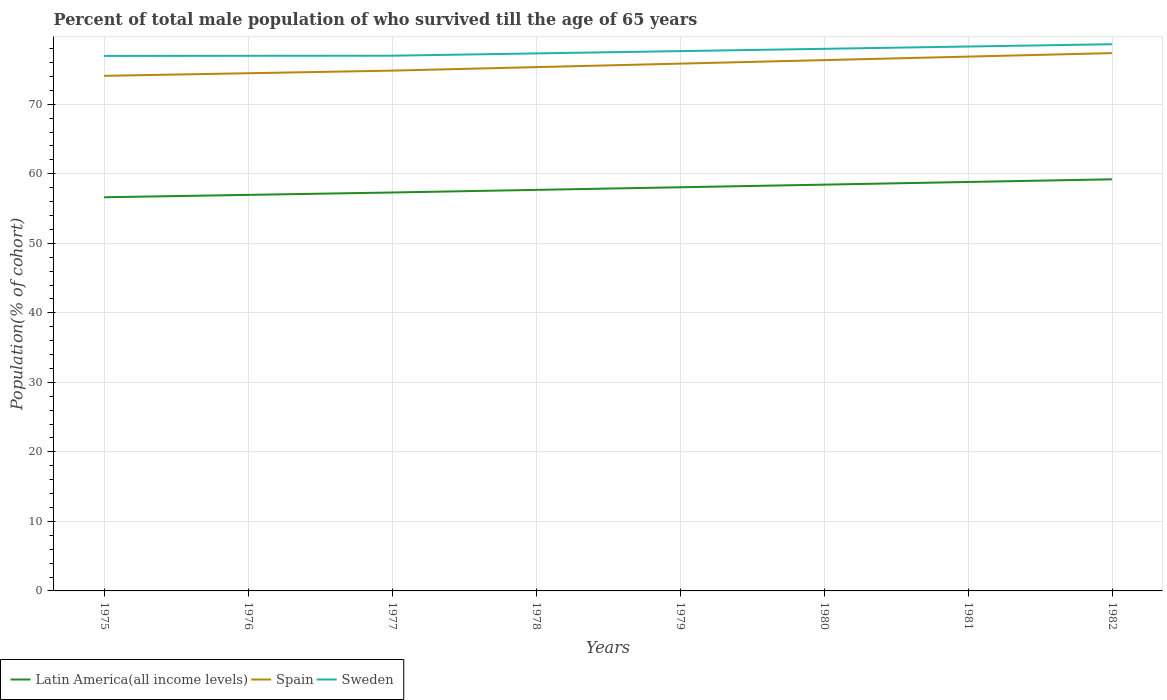Does the line corresponding to Spain intersect with the line corresponding to Sweden?
Give a very brief answer. No. Is the number of lines equal to the number of legend labels?
Keep it short and to the point. Yes. Across all years, what is the maximum percentage of total male population who survived till the age of 65 years in Latin America(all income levels)?
Your answer should be compact. 56.62. In which year was the percentage of total male population who survived till the age of 65 years in Latin America(all income levels) maximum?
Offer a terse response. 1975. What is the total percentage of total male population who survived till the age of 65 years in Sweden in the graph?
Offer a very short reply. -1.65. What is the difference between the highest and the second highest percentage of total male population who survived till the age of 65 years in Spain?
Your answer should be compact. 3.27. What is the difference between the highest and the lowest percentage of total male population who survived till the age of 65 years in Spain?
Your response must be concise. 4. Is the percentage of total male population who survived till the age of 65 years in Sweden strictly greater than the percentage of total male population who survived till the age of 65 years in Latin America(all income levels) over the years?
Your answer should be compact. No. How many years are there in the graph?
Your answer should be compact. 8. What is the difference between two consecutive major ticks on the Y-axis?
Provide a short and direct response. 10. Are the values on the major ticks of Y-axis written in scientific E-notation?
Offer a terse response. No. Does the graph contain any zero values?
Ensure brevity in your answer.  No. How many legend labels are there?
Your response must be concise. 3. How are the legend labels stacked?
Give a very brief answer. Horizontal. What is the title of the graph?
Offer a terse response. Percent of total male population of who survived till the age of 65 years. What is the label or title of the Y-axis?
Your response must be concise. Population(% of cohort). What is the Population(% of cohort) of Latin America(all income levels) in 1975?
Give a very brief answer. 56.62. What is the Population(% of cohort) in Spain in 1975?
Your answer should be very brief. 74.09. What is the Population(% of cohort) of Sweden in 1975?
Provide a succinct answer. 76.96. What is the Population(% of cohort) of Latin America(all income levels) in 1976?
Make the answer very short. 56.97. What is the Population(% of cohort) in Spain in 1976?
Give a very brief answer. 74.46. What is the Population(% of cohort) of Sweden in 1976?
Give a very brief answer. 76.97. What is the Population(% of cohort) in Latin America(all income levels) in 1977?
Provide a succinct answer. 57.31. What is the Population(% of cohort) of Spain in 1977?
Your answer should be compact. 74.84. What is the Population(% of cohort) of Sweden in 1977?
Offer a terse response. 76.99. What is the Population(% of cohort) in Latin America(all income levels) in 1978?
Provide a succinct answer. 57.69. What is the Population(% of cohort) in Spain in 1978?
Provide a succinct answer. 75.34. What is the Population(% of cohort) of Sweden in 1978?
Offer a terse response. 77.32. What is the Population(% of cohort) of Latin America(all income levels) in 1979?
Keep it short and to the point. 58.06. What is the Population(% of cohort) in Spain in 1979?
Offer a terse response. 75.85. What is the Population(% of cohort) in Sweden in 1979?
Give a very brief answer. 77.65. What is the Population(% of cohort) in Latin America(all income levels) in 1980?
Keep it short and to the point. 58.44. What is the Population(% of cohort) in Spain in 1980?
Make the answer very short. 76.35. What is the Population(% of cohort) of Sweden in 1980?
Your response must be concise. 77.98. What is the Population(% of cohort) of Latin America(all income levels) in 1981?
Your answer should be compact. 58.82. What is the Population(% of cohort) of Spain in 1981?
Offer a terse response. 76.86. What is the Population(% of cohort) of Sweden in 1981?
Provide a short and direct response. 78.31. What is the Population(% of cohort) of Latin America(all income levels) in 1982?
Keep it short and to the point. 59.21. What is the Population(% of cohort) in Spain in 1982?
Your answer should be compact. 77.36. What is the Population(% of cohort) of Sweden in 1982?
Your answer should be very brief. 78.64. Across all years, what is the maximum Population(% of cohort) of Latin America(all income levels)?
Your response must be concise. 59.21. Across all years, what is the maximum Population(% of cohort) of Spain?
Your answer should be compact. 77.36. Across all years, what is the maximum Population(% of cohort) in Sweden?
Your response must be concise. 78.64. Across all years, what is the minimum Population(% of cohort) of Latin America(all income levels)?
Ensure brevity in your answer.  56.62. Across all years, what is the minimum Population(% of cohort) of Spain?
Ensure brevity in your answer.  74.09. Across all years, what is the minimum Population(% of cohort) in Sweden?
Offer a terse response. 76.96. What is the total Population(% of cohort) of Latin America(all income levels) in the graph?
Give a very brief answer. 463.12. What is the total Population(% of cohort) in Spain in the graph?
Give a very brief answer. 605.15. What is the total Population(% of cohort) of Sweden in the graph?
Offer a terse response. 620.8. What is the difference between the Population(% of cohort) in Latin America(all income levels) in 1975 and that in 1976?
Keep it short and to the point. -0.34. What is the difference between the Population(% of cohort) of Spain in 1975 and that in 1976?
Your answer should be compact. -0.37. What is the difference between the Population(% of cohort) in Sweden in 1975 and that in 1976?
Offer a terse response. -0.01. What is the difference between the Population(% of cohort) of Latin America(all income levels) in 1975 and that in 1977?
Ensure brevity in your answer.  -0.68. What is the difference between the Population(% of cohort) of Spain in 1975 and that in 1977?
Offer a very short reply. -0.75. What is the difference between the Population(% of cohort) of Sweden in 1975 and that in 1977?
Offer a terse response. -0.03. What is the difference between the Population(% of cohort) in Latin America(all income levels) in 1975 and that in 1978?
Give a very brief answer. -1.06. What is the difference between the Population(% of cohort) of Spain in 1975 and that in 1978?
Provide a succinct answer. -1.25. What is the difference between the Population(% of cohort) in Sweden in 1975 and that in 1978?
Provide a short and direct response. -0.36. What is the difference between the Population(% of cohort) of Latin America(all income levels) in 1975 and that in 1979?
Your answer should be compact. -1.44. What is the difference between the Population(% of cohort) in Spain in 1975 and that in 1979?
Your response must be concise. -1.76. What is the difference between the Population(% of cohort) of Sweden in 1975 and that in 1979?
Keep it short and to the point. -0.69. What is the difference between the Population(% of cohort) in Latin America(all income levels) in 1975 and that in 1980?
Your answer should be compact. -1.82. What is the difference between the Population(% of cohort) of Spain in 1975 and that in 1980?
Provide a short and direct response. -2.26. What is the difference between the Population(% of cohort) of Sweden in 1975 and that in 1980?
Provide a short and direct response. -1.02. What is the difference between the Population(% of cohort) of Latin America(all income levels) in 1975 and that in 1981?
Offer a terse response. -2.2. What is the difference between the Population(% of cohort) in Spain in 1975 and that in 1981?
Your answer should be compact. -2.77. What is the difference between the Population(% of cohort) of Sweden in 1975 and that in 1981?
Provide a short and direct response. -1.35. What is the difference between the Population(% of cohort) in Latin America(all income levels) in 1975 and that in 1982?
Your answer should be compact. -2.58. What is the difference between the Population(% of cohort) in Spain in 1975 and that in 1982?
Give a very brief answer. -3.27. What is the difference between the Population(% of cohort) of Sweden in 1975 and that in 1982?
Offer a terse response. -1.68. What is the difference between the Population(% of cohort) in Latin America(all income levels) in 1976 and that in 1977?
Your answer should be very brief. -0.34. What is the difference between the Population(% of cohort) of Spain in 1976 and that in 1977?
Your answer should be compact. -0.37. What is the difference between the Population(% of cohort) in Sweden in 1976 and that in 1977?
Ensure brevity in your answer.  -0.01. What is the difference between the Population(% of cohort) in Latin America(all income levels) in 1976 and that in 1978?
Provide a short and direct response. -0.72. What is the difference between the Population(% of cohort) in Spain in 1976 and that in 1978?
Your answer should be compact. -0.88. What is the difference between the Population(% of cohort) of Sweden in 1976 and that in 1978?
Provide a short and direct response. -0.34. What is the difference between the Population(% of cohort) in Latin America(all income levels) in 1976 and that in 1979?
Your response must be concise. -1.1. What is the difference between the Population(% of cohort) of Spain in 1976 and that in 1979?
Your answer should be very brief. -1.38. What is the difference between the Population(% of cohort) of Sweden in 1976 and that in 1979?
Keep it short and to the point. -0.67. What is the difference between the Population(% of cohort) in Latin America(all income levels) in 1976 and that in 1980?
Your response must be concise. -1.47. What is the difference between the Population(% of cohort) in Spain in 1976 and that in 1980?
Keep it short and to the point. -1.89. What is the difference between the Population(% of cohort) of Sweden in 1976 and that in 1980?
Ensure brevity in your answer.  -1. What is the difference between the Population(% of cohort) in Latin America(all income levels) in 1976 and that in 1981?
Ensure brevity in your answer.  -1.86. What is the difference between the Population(% of cohort) of Spain in 1976 and that in 1981?
Make the answer very short. -2.39. What is the difference between the Population(% of cohort) of Sweden in 1976 and that in 1981?
Your answer should be very brief. -1.33. What is the difference between the Population(% of cohort) in Latin America(all income levels) in 1976 and that in 1982?
Provide a short and direct response. -2.24. What is the difference between the Population(% of cohort) of Spain in 1976 and that in 1982?
Provide a succinct answer. -2.9. What is the difference between the Population(% of cohort) in Sweden in 1976 and that in 1982?
Ensure brevity in your answer.  -1.67. What is the difference between the Population(% of cohort) in Latin America(all income levels) in 1977 and that in 1978?
Provide a succinct answer. -0.38. What is the difference between the Population(% of cohort) of Spain in 1977 and that in 1978?
Offer a very short reply. -0.5. What is the difference between the Population(% of cohort) in Sweden in 1977 and that in 1978?
Offer a very short reply. -0.33. What is the difference between the Population(% of cohort) in Latin America(all income levels) in 1977 and that in 1979?
Give a very brief answer. -0.75. What is the difference between the Population(% of cohort) of Spain in 1977 and that in 1979?
Offer a very short reply. -1.01. What is the difference between the Population(% of cohort) of Sweden in 1977 and that in 1979?
Ensure brevity in your answer.  -0.66. What is the difference between the Population(% of cohort) of Latin America(all income levels) in 1977 and that in 1980?
Offer a terse response. -1.13. What is the difference between the Population(% of cohort) in Spain in 1977 and that in 1980?
Make the answer very short. -1.51. What is the difference between the Population(% of cohort) in Sweden in 1977 and that in 1980?
Keep it short and to the point. -0.99. What is the difference between the Population(% of cohort) of Latin America(all income levels) in 1977 and that in 1981?
Provide a short and direct response. -1.52. What is the difference between the Population(% of cohort) of Spain in 1977 and that in 1981?
Keep it short and to the point. -2.02. What is the difference between the Population(% of cohort) of Sweden in 1977 and that in 1981?
Your answer should be compact. -1.32. What is the difference between the Population(% of cohort) in Latin America(all income levels) in 1977 and that in 1982?
Offer a terse response. -1.9. What is the difference between the Population(% of cohort) in Spain in 1977 and that in 1982?
Your answer should be compact. -2.52. What is the difference between the Population(% of cohort) in Sweden in 1977 and that in 1982?
Provide a succinct answer. -1.65. What is the difference between the Population(% of cohort) in Latin America(all income levels) in 1978 and that in 1979?
Your response must be concise. -0.38. What is the difference between the Population(% of cohort) of Spain in 1978 and that in 1979?
Offer a terse response. -0.5. What is the difference between the Population(% of cohort) of Sweden in 1978 and that in 1979?
Provide a succinct answer. -0.33. What is the difference between the Population(% of cohort) in Latin America(all income levels) in 1978 and that in 1980?
Offer a very short reply. -0.75. What is the difference between the Population(% of cohort) in Spain in 1978 and that in 1980?
Give a very brief answer. -1.01. What is the difference between the Population(% of cohort) in Sweden in 1978 and that in 1980?
Your response must be concise. -0.66. What is the difference between the Population(% of cohort) of Latin America(all income levels) in 1978 and that in 1981?
Your response must be concise. -1.14. What is the difference between the Population(% of cohort) in Spain in 1978 and that in 1981?
Give a very brief answer. -1.51. What is the difference between the Population(% of cohort) of Sweden in 1978 and that in 1981?
Offer a very short reply. -0.99. What is the difference between the Population(% of cohort) of Latin America(all income levels) in 1978 and that in 1982?
Make the answer very short. -1.52. What is the difference between the Population(% of cohort) of Spain in 1978 and that in 1982?
Your answer should be very brief. -2.02. What is the difference between the Population(% of cohort) of Sweden in 1978 and that in 1982?
Offer a terse response. -1.32. What is the difference between the Population(% of cohort) in Latin America(all income levels) in 1979 and that in 1980?
Give a very brief answer. -0.38. What is the difference between the Population(% of cohort) in Spain in 1979 and that in 1980?
Your answer should be very brief. -0.5. What is the difference between the Population(% of cohort) in Sweden in 1979 and that in 1980?
Ensure brevity in your answer.  -0.33. What is the difference between the Population(% of cohort) of Latin America(all income levels) in 1979 and that in 1981?
Your answer should be compact. -0.76. What is the difference between the Population(% of cohort) of Spain in 1979 and that in 1981?
Keep it short and to the point. -1.01. What is the difference between the Population(% of cohort) in Sweden in 1979 and that in 1981?
Provide a succinct answer. -0.66. What is the difference between the Population(% of cohort) in Latin America(all income levels) in 1979 and that in 1982?
Give a very brief answer. -1.15. What is the difference between the Population(% of cohort) of Spain in 1979 and that in 1982?
Ensure brevity in your answer.  -1.51. What is the difference between the Population(% of cohort) of Sweden in 1979 and that in 1982?
Ensure brevity in your answer.  -0.99. What is the difference between the Population(% of cohort) of Latin America(all income levels) in 1980 and that in 1981?
Offer a terse response. -0.38. What is the difference between the Population(% of cohort) in Spain in 1980 and that in 1981?
Provide a short and direct response. -0.5. What is the difference between the Population(% of cohort) of Sweden in 1980 and that in 1981?
Ensure brevity in your answer.  -0.33. What is the difference between the Population(% of cohort) in Latin America(all income levels) in 1980 and that in 1982?
Keep it short and to the point. -0.77. What is the difference between the Population(% of cohort) of Spain in 1980 and that in 1982?
Give a very brief answer. -1.01. What is the difference between the Population(% of cohort) in Sweden in 1980 and that in 1982?
Make the answer very short. -0.66. What is the difference between the Population(% of cohort) of Latin America(all income levels) in 1981 and that in 1982?
Offer a very short reply. -0.38. What is the difference between the Population(% of cohort) in Spain in 1981 and that in 1982?
Offer a very short reply. -0.5. What is the difference between the Population(% of cohort) of Sweden in 1981 and that in 1982?
Offer a very short reply. -0.33. What is the difference between the Population(% of cohort) of Latin America(all income levels) in 1975 and the Population(% of cohort) of Spain in 1976?
Your answer should be compact. -17.84. What is the difference between the Population(% of cohort) in Latin America(all income levels) in 1975 and the Population(% of cohort) in Sweden in 1976?
Your response must be concise. -20.35. What is the difference between the Population(% of cohort) in Spain in 1975 and the Population(% of cohort) in Sweden in 1976?
Keep it short and to the point. -2.88. What is the difference between the Population(% of cohort) in Latin America(all income levels) in 1975 and the Population(% of cohort) in Spain in 1977?
Your answer should be very brief. -18.21. What is the difference between the Population(% of cohort) of Latin America(all income levels) in 1975 and the Population(% of cohort) of Sweden in 1977?
Keep it short and to the point. -20.36. What is the difference between the Population(% of cohort) in Spain in 1975 and the Population(% of cohort) in Sweden in 1977?
Your answer should be very brief. -2.89. What is the difference between the Population(% of cohort) in Latin America(all income levels) in 1975 and the Population(% of cohort) in Spain in 1978?
Provide a succinct answer. -18.72. What is the difference between the Population(% of cohort) in Latin America(all income levels) in 1975 and the Population(% of cohort) in Sweden in 1978?
Ensure brevity in your answer.  -20.69. What is the difference between the Population(% of cohort) of Spain in 1975 and the Population(% of cohort) of Sweden in 1978?
Provide a short and direct response. -3.23. What is the difference between the Population(% of cohort) in Latin America(all income levels) in 1975 and the Population(% of cohort) in Spain in 1979?
Provide a succinct answer. -19.22. What is the difference between the Population(% of cohort) of Latin America(all income levels) in 1975 and the Population(% of cohort) of Sweden in 1979?
Provide a succinct answer. -21.02. What is the difference between the Population(% of cohort) of Spain in 1975 and the Population(% of cohort) of Sweden in 1979?
Keep it short and to the point. -3.56. What is the difference between the Population(% of cohort) in Latin America(all income levels) in 1975 and the Population(% of cohort) in Spain in 1980?
Offer a terse response. -19.73. What is the difference between the Population(% of cohort) of Latin America(all income levels) in 1975 and the Population(% of cohort) of Sweden in 1980?
Make the answer very short. -21.35. What is the difference between the Population(% of cohort) of Spain in 1975 and the Population(% of cohort) of Sweden in 1980?
Your response must be concise. -3.89. What is the difference between the Population(% of cohort) of Latin America(all income levels) in 1975 and the Population(% of cohort) of Spain in 1981?
Your answer should be very brief. -20.23. What is the difference between the Population(% of cohort) in Latin America(all income levels) in 1975 and the Population(% of cohort) in Sweden in 1981?
Your response must be concise. -21.68. What is the difference between the Population(% of cohort) in Spain in 1975 and the Population(% of cohort) in Sweden in 1981?
Keep it short and to the point. -4.22. What is the difference between the Population(% of cohort) in Latin America(all income levels) in 1975 and the Population(% of cohort) in Spain in 1982?
Make the answer very short. -20.74. What is the difference between the Population(% of cohort) in Latin America(all income levels) in 1975 and the Population(% of cohort) in Sweden in 1982?
Offer a very short reply. -22.01. What is the difference between the Population(% of cohort) in Spain in 1975 and the Population(% of cohort) in Sweden in 1982?
Provide a succinct answer. -4.55. What is the difference between the Population(% of cohort) of Latin America(all income levels) in 1976 and the Population(% of cohort) of Spain in 1977?
Make the answer very short. -17.87. What is the difference between the Population(% of cohort) in Latin America(all income levels) in 1976 and the Population(% of cohort) in Sweden in 1977?
Offer a very short reply. -20.02. What is the difference between the Population(% of cohort) in Spain in 1976 and the Population(% of cohort) in Sweden in 1977?
Provide a short and direct response. -2.52. What is the difference between the Population(% of cohort) of Latin America(all income levels) in 1976 and the Population(% of cohort) of Spain in 1978?
Provide a short and direct response. -18.38. What is the difference between the Population(% of cohort) in Latin America(all income levels) in 1976 and the Population(% of cohort) in Sweden in 1978?
Make the answer very short. -20.35. What is the difference between the Population(% of cohort) of Spain in 1976 and the Population(% of cohort) of Sweden in 1978?
Offer a terse response. -2.85. What is the difference between the Population(% of cohort) in Latin America(all income levels) in 1976 and the Population(% of cohort) in Spain in 1979?
Ensure brevity in your answer.  -18.88. What is the difference between the Population(% of cohort) of Latin America(all income levels) in 1976 and the Population(% of cohort) of Sweden in 1979?
Keep it short and to the point. -20.68. What is the difference between the Population(% of cohort) in Spain in 1976 and the Population(% of cohort) in Sweden in 1979?
Give a very brief answer. -3.18. What is the difference between the Population(% of cohort) of Latin America(all income levels) in 1976 and the Population(% of cohort) of Spain in 1980?
Make the answer very short. -19.39. What is the difference between the Population(% of cohort) in Latin America(all income levels) in 1976 and the Population(% of cohort) in Sweden in 1980?
Offer a terse response. -21.01. What is the difference between the Population(% of cohort) of Spain in 1976 and the Population(% of cohort) of Sweden in 1980?
Provide a short and direct response. -3.51. What is the difference between the Population(% of cohort) of Latin America(all income levels) in 1976 and the Population(% of cohort) of Spain in 1981?
Ensure brevity in your answer.  -19.89. What is the difference between the Population(% of cohort) in Latin America(all income levels) in 1976 and the Population(% of cohort) in Sweden in 1981?
Make the answer very short. -21.34. What is the difference between the Population(% of cohort) in Spain in 1976 and the Population(% of cohort) in Sweden in 1981?
Provide a short and direct response. -3.84. What is the difference between the Population(% of cohort) in Latin America(all income levels) in 1976 and the Population(% of cohort) in Spain in 1982?
Give a very brief answer. -20.39. What is the difference between the Population(% of cohort) in Latin America(all income levels) in 1976 and the Population(% of cohort) in Sweden in 1982?
Offer a terse response. -21.67. What is the difference between the Population(% of cohort) in Spain in 1976 and the Population(% of cohort) in Sweden in 1982?
Your response must be concise. -4.17. What is the difference between the Population(% of cohort) of Latin America(all income levels) in 1977 and the Population(% of cohort) of Spain in 1978?
Give a very brief answer. -18.03. What is the difference between the Population(% of cohort) in Latin America(all income levels) in 1977 and the Population(% of cohort) in Sweden in 1978?
Offer a terse response. -20.01. What is the difference between the Population(% of cohort) of Spain in 1977 and the Population(% of cohort) of Sweden in 1978?
Your answer should be compact. -2.48. What is the difference between the Population(% of cohort) in Latin America(all income levels) in 1977 and the Population(% of cohort) in Spain in 1979?
Ensure brevity in your answer.  -18.54. What is the difference between the Population(% of cohort) of Latin America(all income levels) in 1977 and the Population(% of cohort) of Sweden in 1979?
Give a very brief answer. -20.34. What is the difference between the Population(% of cohort) in Spain in 1977 and the Population(% of cohort) in Sweden in 1979?
Provide a succinct answer. -2.81. What is the difference between the Population(% of cohort) of Latin America(all income levels) in 1977 and the Population(% of cohort) of Spain in 1980?
Your answer should be very brief. -19.04. What is the difference between the Population(% of cohort) of Latin America(all income levels) in 1977 and the Population(% of cohort) of Sweden in 1980?
Ensure brevity in your answer.  -20.67. What is the difference between the Population(% of cohort) of Spain in 1977 and the Population(% of cohort) of Sweden in 1980?
Offer a very short reply. -3.14. What is the difference between the Population(% of cohort) in Latin America(all income levels) in 1977 and the Population(% of cohort) in Spain in 1981?
Ensure brevity in your answer.  -19.55. What is the difference between the Population(% of cohort) of Latin America(all income levels) in 1977 and the Population(% of cohort) of Sweden in 1981?
Make the answer very short. -21. What is the difference between the Population(% of cohort) of Spain in 1977 and the Population(% of cohort) of Sweden in 1981?
Your response must be concise. -3.47. What is the difference between the Population(% of cohort) of Latin America(all income levels) in 1977 and the Population(% of cohort) of Spain in 1982?
Provide a succinct answer. -20.05. What is the difference between the Population(% of cohort) of Latin America(all income levels) in 1977 and the Population(% of cohort) of Sweden in 1982?
Make the answer very short. -21.33. What is the difference between the Population(% of cohort) in Spain in 1977 and the Population(% of cohort) in Sweden in 1982?
Give a very brief answer. -3.8. What is the difference between the Population(% of cohort) of Latin America(all income levels) in 1978 and the Population(% of cohort) of Spain in 1979?
Keep it short and to the point. -18.16. What is the difference between the Population(% of cohort) in Latin America(all income levels) in 1978 and the Population(% of cohort) in Sweden in 1979?
Offer a very short reply. -19.96. What is the difference between the Population(% of cohort) in Spain in 1978 and the Population(% of cohort) in Sweden in 1979?
Provide a short and direct response. -2.3. What is the difference between the Population(% of cohort) in Latin America(all income levels) in 1978 and the Population(% of cohort) in Spain in 1980?
Provide a short and direct response. -18.67. What is the difference between the Population(% of cohort) in Latin America(all income levels) in 1978 and the Population(% of cohort) in Sweden in 1980?
Provide a succinct answer. -20.29. What is the difference between the Population(% of cohort) of Spain in 1978 and the Population(% of cohort) of Sweden in 1980?
Your response must be concise. -2.63. What is the difference between the Population(% of cohort) of Latin America(all income levels) in 1978 and the Population(% of cohort) of Spain in 1981?
Offer a terse response. -19.17. What is the difference between the Population(% of cohort) of Latin America(all income levels) in 1978 and the Population(% of cohort) of Sweden in 1981?
Make the answer very short. -20.62. What is the difference between the Population(% of cohort) of Spain in 1978 and the Population(% of cohort) of Sweden in 1981?
Provide a succinct answer. -2.96. What is the difference between the Population(% of cohort) of Latin America(all income levels) in 1978 and the Population(% of cohort) of Spain in 1982?
Offer a very short reply. -19.68. What is the difference between the Population(% of cohort) in Latin America(all income levels) in 1978 and the Population(% of cohort) in Sweden in 1982?
Your answer should be very brief. -20.95. What is the difference between the Population(% of cohort) of Spain in 1978 and the Population(% of cohort) of Sweden in 1982?
Give a very brief answer. -3.29. What is the difference between the Population(% of cohort) of Latin America(all income levels) in 1979 and the Population(% of cohort) of Spain in 1980?
Offer a very short reply. -18.29. What is the difference between the Population(% of cohort) in Latin America(all income levels) in 1979 and the Population(% of cohort) in Sweden in 1980?
Offer a terse response. -19.91. What is the difference between the Population(% of cohort) in Spain in 1979 and the Population(% of cohort) in Sweden in 1980?
Give a very brief answer. -2.13. What is the difference between the Population(% of cohort) of Latin America(all income levels) in 1979 and the Population(% of cohort) of Spain in 1981?
Give a very brief answer. -18.79. What is the difference between the Population(% of cohort) in Latin America(all income levels) in 1979 and the Population(% of cohort) in Sweden in 1981?
Your response must be concise. -20.24. What is the difference between the Population(% of cohort) of Spain in 1979 and the Population(% of cohort) of Sweden in 1981?
Your answer should be compact. -2.46. What is the difference between the Population(% of cohort) in Latin America(all income levels) in 1979 and the Population(% of cohort) in Spain in 1982?
Offer a very short reply. -19.3. What is the difference between the Population(% of cohort) of Latin America(all income levels) in 1979 and the Population(% of cohort) of Sweden in 1982?
Keep it short and to the point. -20.57. What is the difference between the Population(% of cohort) of Spain in 1979 and the Population(% of cohort) of Sweden in 1982?
Make the answer very short. -2.79. What is the difference between the Population(% of cohort) of Latin America(all income levels) in 1980 and the Population(% of cohort) of Spain in 1981?
Provide a succinct answer. -18.42. What is the difference between the Population(% of cohort) of Latin America(all income levels) in 1980 and the Population(% of cohort) of Sweden in 1981?
Give a very brief answer. -19.87. What is the difference between the Population(% of cohort) of Spain in 1980 and the Population(% of cohort) of Sweden in 1981?
Offer a very short reply. -1.95. What is the difference between the Population(% of cohort) in Latin America(all income levels) in 1980 and the Population(% of cohort) in Spain in 1982?
Your answer should be compact. -18.92. What is the difference between the Population(% of cohort) of Latin America(all income levels) in 1980 and the Population(% of cohort) of Sweden in 1982?
Keep it short and to the point. -20.2. What is the difference between the Population(% of cohort) in Spain in 1980 and the Population(% of cohort) in Sweden in 1982?
Provide a short and direct response. -2.28. What is the difference between the Population(% of cohort) of Latin America(all income levels) in 1981 and the Population(% of cohort) of Spain in 1982?
Offer a very short reply. -18.54. What is the difference between the Population(% of cohort) of Latin America(all income levels) in 1981 and the Population(% of cohort) of Sweden in 1982?
Ensure brevity in your answer.  -19.81. What is the difference between the Population(% of cohort) of Spain in 1981 and the Population(% of cohort) of Sweden in 1982?
Ensure brevity in your answer.  -1.78. What is the average Population(% of cohort) of Latin America(all income levels) per year?
Your answer should be compact. 57.89. What is the average Population(% of cohort) of Spain per year?
Provide a short and direct response. 75.64. What is the average Population(% of cohort) in Sweden per year?
Your answer should be compact. 77.6. In the year 1975, what is the difference between the Population(% of cohort) of Latin America(all income levels) and Population(% of cohort) of Spain?
Provide a short and direct response. -17.47. In the year 1975, what is the difference between the Population(% of cohort) in Latin America(all income levels) and Population(% of cohort) in Sweden?
Your answer should be very brief. -20.33. In the year 1975, what is the difference between the Population(% of cohort) in Spain and Population(% of cohort) in Sweden?
Provide a succinct answer. -2.87. In the year 1976, what is the difference between the Population(% of cohort) of Latin America(all income levels) and Population(% of cohort) of Spain?
Make the answer very short. -17.5. In the year 1976, what is the difference between the Population(% of cohort) of Latin America(all income levels) and Population(% of cohort) of Sweden?
Provide a succinct answer. -20.01. In the year 1976, what is the difference between the Population(% of cohort) in Spain and Population(% of cohort) in Sweden?
Your response must be concise. -2.51. In the year 1977, what is the difference between the Population(% of cohort) of Latin America(all income levels) and Population(% of cohort) of Spain?
Give a very brief answer. -17.53. In the year 1977, what is the difference between the Population(% of cohort) in Latin America(all income levels) and Population(% of cohort) in Sweden?
Provide a short and direct response. -19.68. In the year 1977, what is the difference between the Population(% of cohort) of Spain and Population(% of cohort) of Sweden?
Your answer should be compact. -2.15. In the year 1978, what is the difference between the Population(% of cohort) of Latin America(all income levels) and Population(% of cohort) of Spain?
Give a very brief answer. -17.66. In the year 1978, what is the difference between the Population(% of cohort) of Latin America(all income levels) and Population(% of cohort) of Sweden?
Your answer should be very brief. -19.63. In the year 1978, what is the difference between the Population(% of cohort) of Spain and Population(% of cohort) of Sweden?
Your response must be concise. -1.97. In the year 1979, what is the difference between the Population(% of cohort) of Latin America(all income levels) and Population(% of cohort) of Spain?
Ensure brevity in your answer.  -17.79. In the year 1979, what is the difference between the Population(% of cohort) in Latin America(all income levels) and Population(% of cohort) in Sweden?
Your answer should be compact. -19.58. In the year 1979, what is the difference between the Population(% of cohort) in Spain and Population(% of cohort) in Sweden?
Provide a short and direct response. -1.8. In the year 1980, what is the difference between the Population(% of cohort) in Latin America(all income levels) and Population(% of cohort) in Spain?
Provide a succinct answer. -17.91. In the year 1980, what is the difference between the Population(% of cohort) in Latin America(all income levels) and Population(% of cohort) in Sweden?
Your answer should be compact. -19.54. In the year 1980, what is the difference between the Population(% of cohort) in Spain and Population(% of cohort) in Sweden?
Keep it short and to the point. -1.62. In the year 1981, what is the difference between the Population(% of cohort) of Latin America(all income levels) and Population(% of cohort) of Spain?
Provide a short and direct response. -18.03. In the year 1981, what is the difference between the Population(% of cohort) of Latin America(all income levels) and Population(% of cohort) of Sweden?
Give a very brief answer. -19.48. In the year 1981, what is the difference between the Population(% of cohort) of Spain and Population(% of cohort) of Sweden?
Give a very brief answer. -1.45. In the year 1982, what is the difference between the Population(% of cohort) in Latin America(all income levels) and Population(% of cohort) in Spain?
Offer a terse response. -18.15. In the year 1982, what is the difference between the Population(% of cohort) of Latin America(all income levels) and Population(% of cohort) of Sweden?
Keep it short and to the point. -19.43. In the year 1982, what is the difference between the Population(% of cohort) of Spain and Population(% of cohort) of Sweden?
Your answer should be very brief. -1.28. What is the ratio of the Population(% of cohort) in Latin America(all income levels) in 1975 to that in 1976?
Provide a short and direct response. 0.99. What is the ratio of the Population(% of cohort) in Spain in 1975 to that in 1976?
Keep it short and to the point. 0.99. What is the ratio of the Population(% of cohort) of Sweden in 1975 to that in 1976?
Keep it short and to the point. 1. What is the ratio of the Population(% of cohort) of Latin America(all income levels) in 1975 to that in 1977?
Your response must be concise. 0.99. What is the ratio of the Population(% of cohort) in Latin America(all income levels) in 1975 to that in 1978?
Your answer should be very brief. 0.98. What is the ratio of the Population(% of cohort) in Spain in 1975 to that in 1978?
Your answer should be compact. 0.98. What is the ratio of the Population(% of cohort) of Latin America(all income levels) in 1975 to that in 1979?
Your answer should be very brief. 0.98. What is the ratio of the Population(% of cohort) in Spain in 1975 to that in 1979?
Make the answer very short. 0.98. What is the ratio of the Population(% of cohort) in Latin America(all income levels) in 1975 to that in 1980?
Provide a succinct answer. 0.97. What is the ratio of the Population(% of cohort) of Spain in 1975 to that in 1980?
Keep it short and to the point. 0.97. What is the ratio of the Population(% of cohort) of Sweden in 1975 to that in 1980?
Give a very brief answer. 0.99. What is the ratio of the Population(% of cohort) of Latin America(all income levels) in 1975 to that in 1981?
Offer a very short reply. 0.96. What is the ratio of the Population(% of cohort) of Spain in 1975 to that in 1981?
Offer a very short reply. 0.96. What is the ratio of the Population(% of cohort) of Sweden in 1975 to that in 1981?
Give a very brief answer. 0.98. What is the ratio of the Population(% of cohort) in Latin America(all income levels) in 1975 to that in 1982?
Your answer should be very brief. 0.96. What is the ratio of the Population(% of cohort) in Spain in 1975 to that in 1982?
Give a very brief answer. 0.96. What is the ratio of the Population(% of cohort) in Sweden in 1975 to that in 1982?
Ensure brevity in your answer.  0.98. What is the ratio of the Population(% of cohort) in Sweden in 1976 to that in 1977?
Offer a very short reply. 1. What is the ratio of the Population(% of cohort) in Latin America(all income levels) in 1976 to that in 1978?
Make the answer very short. 0.99. What is the ratio of the Population(% of cohort) in Spain in 1976 to that in 1978?
Your response must be concise. 0.99. What is the ratio of the Population(% of cohort) of Latin America(all income levels) in 1976 to that in 1979?
Provide a succinct answer. 0.98. What is the ratio of the Population(% of cohort) of Spain in 1976 to that in 1979?
Your answer should be very brief. 0.98. What is the ratio of the Population(% of cohort) in Sweden in 1976 to that in 1979?
Ensure brevity in your answer.  0.99. What is the ratio of the Population(% of cohort) in Latin America(all income levels) in 1976 to that in 1980?
Give a very brief answer. 0.97. What is the ratio of the Population(% of cohort) of Spain in 1976 to that in 1980?
Provide a short and direct response. 0.98. What is the ratio of the Population(% of cohort) of Sweden in 1976 to that in 1980?
Your answer should be very brief. 0.99. What is the ratio of the Population(% of cohort) in Latin America(all income levels) in 1976 to that in 1981?
Offer a terse response. 0.97. What is the ratio of the Population(% of cohort) in Spain in 1976 to that in 1981?
Make the answer very short. 0.97. What is the ratio of the Population(% of cohort) of Sweden in 1976 to that in 1981?
Provide a succinct answer. 0.98. What is the ratio of the Population(% of cohort) of Latin America(all income levels) in 1976 to that in 1982?
Provide a short and direct response. 0.96. What is the ratio of the Population(% of cohort) of Spain in 1976 to that in 1982?
Your answer should be very brief. 0.96. What is the ratio of the Population(% of cohort) in Sweden in 1976 to that in 1982?
Make the answer very short. 0.98. What is the ratio of the Population(% of cohort) of Latin America(all income levels) in 1977 to that in 1978?
Your response must be concise. 0.99. What is the ratio of the Population(% of cohort) of Sweden in 1977 to that in 1978?
Your response must be concise. 1. What is the ratio of the Population(% of cohort) in Latin America(all income levels) in 1977 to that in 1979?
Provide a succinct answer. 0.99. What is the ratio of the Population(% of cohort) of Spain in 1977 to that in 1979?
Provide a succinct answer. 0.99. What is the ratio of the Population(% of cohort) of Latin America(all income levels) in 1977 to that in 1980?
Your answer should be very brief. 0.98. What is the ratio of the Population(% of cohort) of Spain in 1977 to that in 1980?
Give a very brief answer. 0.98. What is the ratio of the Population(% of cohort) in Sweden in 1977 to that in 1980?
Offer a very short reply. 0.99. What is the ratio of the Population(% of cohort) in Latin America(all income levels) in 1977 to that in 1981?
Keep it short and to the point. 0.97. What is the ratio of the Population(% of cohort) of Spain in 1977 to that in 1981?
Make the answer very short. 0.97. What is the ratio of the Population(% of cohort) of Sweden in 1977 to that in 1981?
Your response must be concise. 0.98. What is the ratio of the Population(% of cohort) of Latin America(all income levels) in 1977 to that in 1982?
Offer a very short reply. 0.97. What is the ratio of the Population(% of cohort) of Spain in 1977 to that in 1982?
Make the answer very short. 0.97. What is the ratio of the Population(% of cohort) of Spain in 1978 to that in 1979?
Offer a very short reply. 0.99. What is the ratio of the Population(% of cohort) in Sweden in 1978 to that in 1979?
Keep it short and to the point. 1. What is the ratio of the Population(% of cohort) in Latin America(all income levels) in 1978 to that in 1980?
Provide a short and direct response. 0.99. What is the ratio of the Population(% of cohort) in Spain in 1978 to that in 1980?
Provide a succinct answer. 0.99. What is the ratio of the Population(% of cohort) in Latin America(all income levels) in 1978 to that in 1981?
Give a very brief answer. 0.98. What is the ratio of the Population(% of cohort) in Spain in 1978 to that in 1981?
Give a very brief answer. 0.98. What is the ratio of the Population(% of cohort) in Sweden in 1978 to that in 1981?
Provide a short and direct response. 0.99. What is the ratio of the Population(% of cohort) in Latin America(all income levels) in 1978 to that in 1982?
Make the answer very short. 0.97. What is the ratio of the Population(% of cohort) of Spain in 1978 to that in 1982?
Keep it short and to the point. 0.97. What is the ratio of the Population(% of cohort) of Sweden in 1978 to that in 1982?
Your answer should be compact. 0.98. What is the ratio of the Population(% of cohort) in Latin America(all income levels) in 1979 to that in 1980?
Your answer should be compact. 0.99. What is the ratio of the Population(% of cohort) of Sweden in 1979 to that in 1980?
Ensure brevity in your answer.  1. What is the ratio of the Population(% of cohort) in Latin America(all income levels) in 1979 to that in 1981?
Offer a very short reply. 0.99. What is the ratio of the Population(% of cohort) of Spain in 1979 to that in 1981?
Provide a short and direct response. 0.99. What is the ratio of the Population(% of cohort) in Latin America(all income levels) in 1979 to that in 1982?
Your answer should be very brief. 0.98. What is the ratio of the Population(% of cohort) in Spain in 1979 to that in 1982?
Give a very brief answer. 0.98. What is the ratio of the Population(% of cohort) of Sweden in 1979 to that in 1982?
Your answer should be compact. 0.99. What is the ratio of the Population(% of cohort) in Spain in 1980 to that in 1981?
Keep it short and to the point. 0.99. What is the ratio of the Population(% of cohort) of Spain in 1980 to that in 1982?
Your answer should be very brief. 0.99. What is the ratio of the Population(% of cohort) of Spain in 1981 to that in 1982?
Provide a succinct answer. 0.99. What is the difference between the highest and the second highest Population(% of cohort) in Latin America(all income levels)?
Your response must be concise. 0.38. What is the difference between the highest and the second highest Population(% of cohort) in Spain?
Make the answer very short. 0.5. What is the difference between the highest and the second highest Population(% of cohort) in Sweden?
Ensure brevity in your answer.  0.33. What is the difference between the highest and the lowest Population(% of cohort) in Latin America(all income levels)?
Your response must be concise. 2.58. What is the difference between the highest and the lowest Population(% of cohort) in Spain?
Offer a terse response. 3.27. What is the difference between the highest and the lowest Population(% of cohort) in Sweden?
Keep it short and to the point. 1.68. 